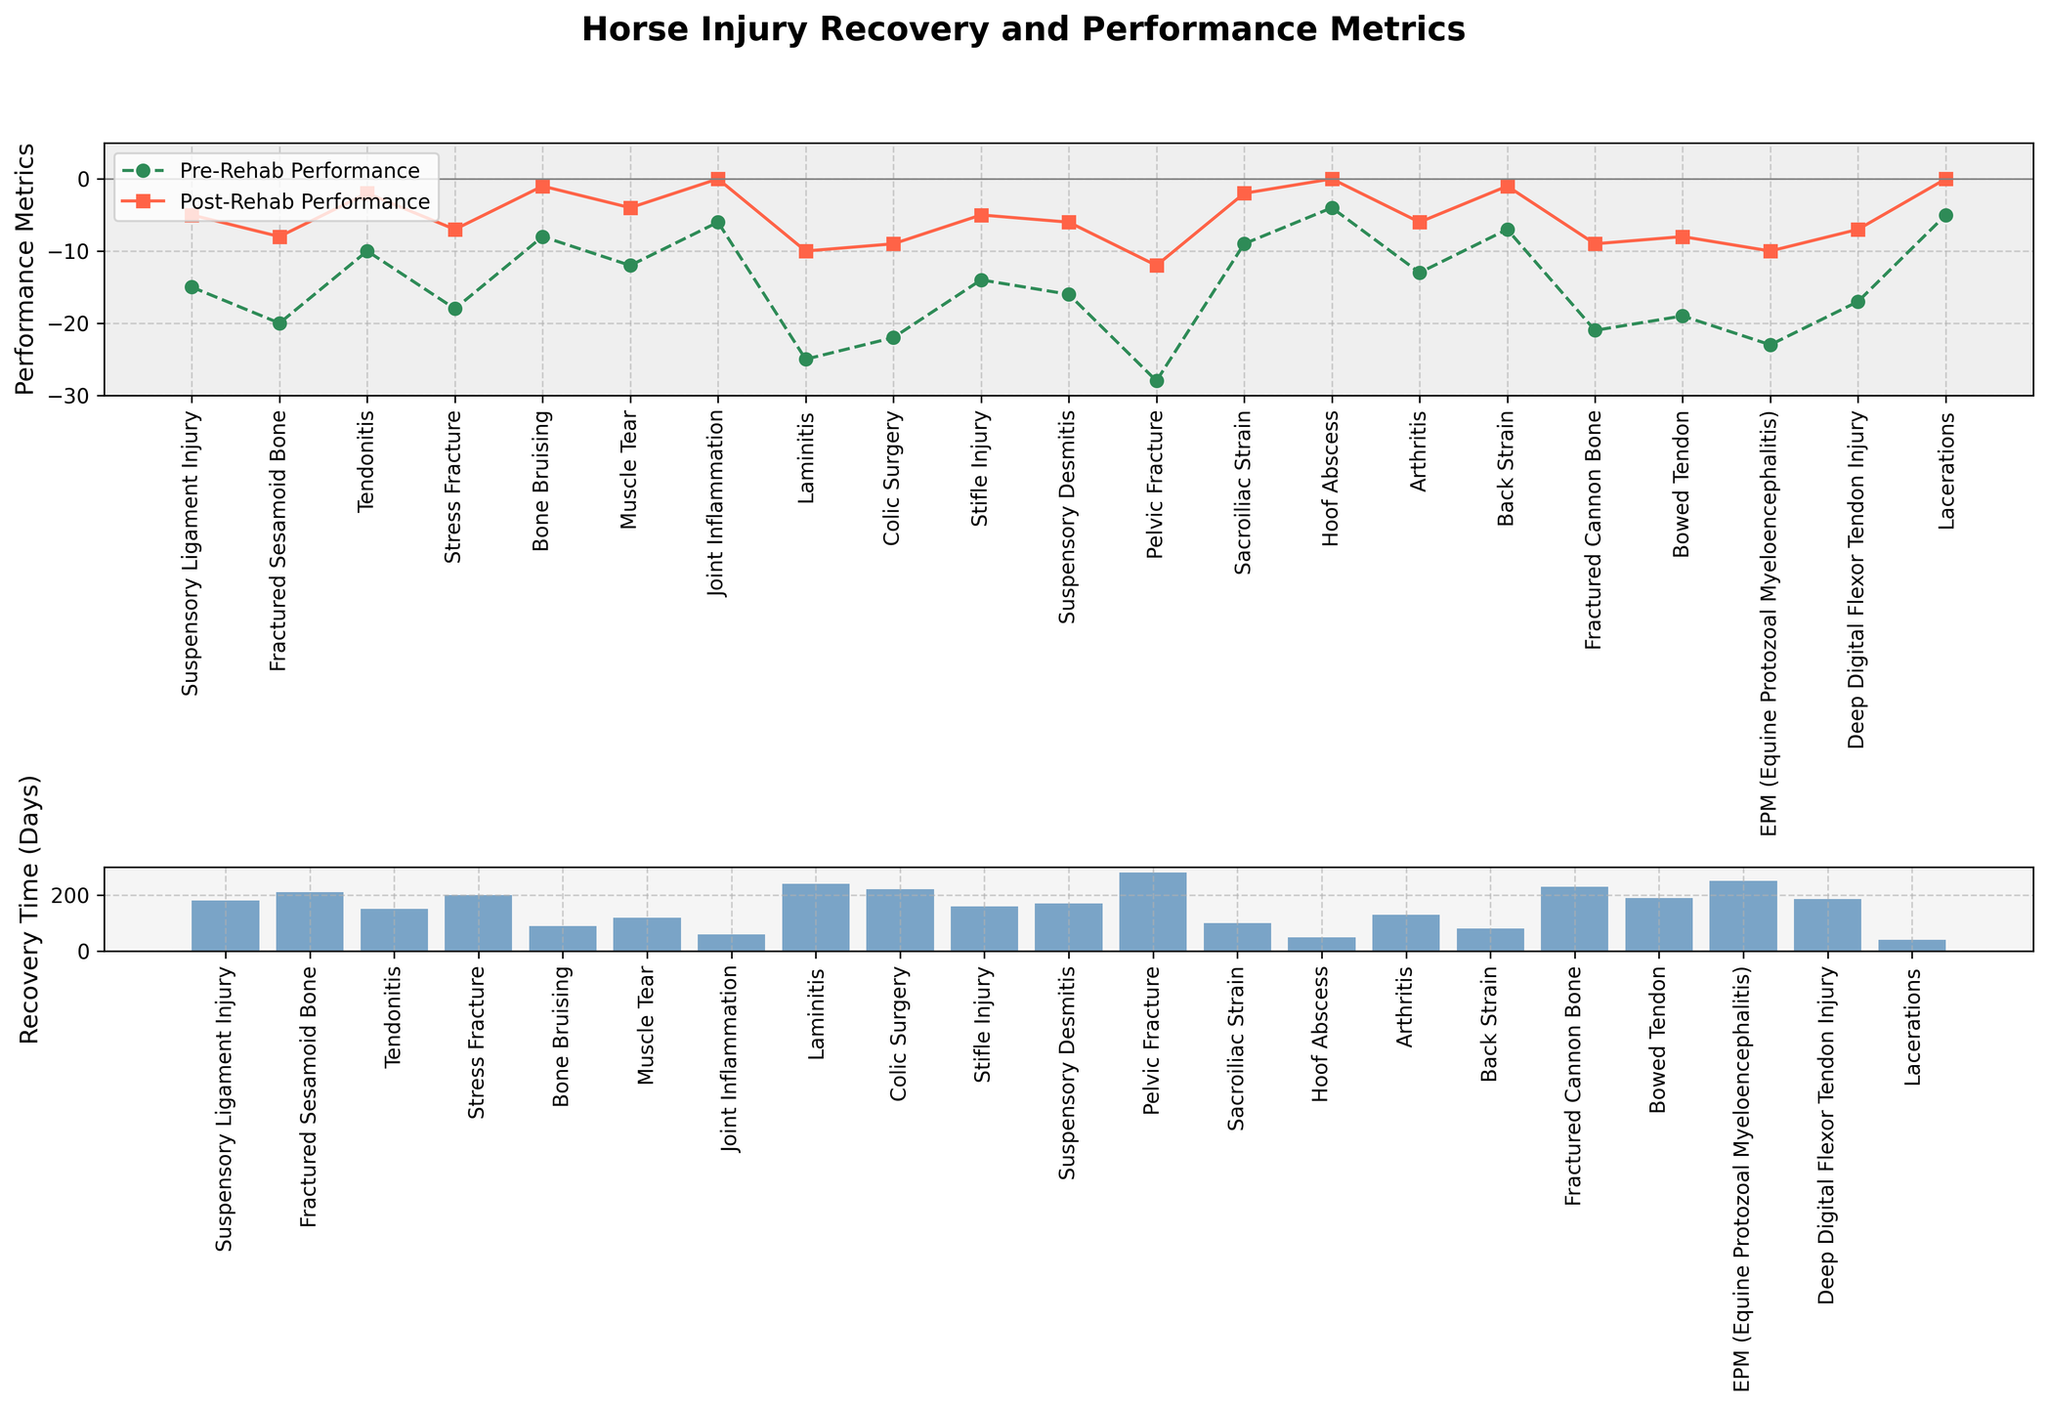What is the average recovery time for suspensory ligament injury and tendonitis? To find the average, add the recovery times for the suspensory ligament injury (180 days) and tendonitis (150 days) and divide by 2: (180 + 150) / 2 = 165 days
Answer: 165 days Which injury has the most significant improvement in performance metrics from pre-rehab to post-rehab? By comparing the differences between pre-rehab and post-rehab performance for each injury, the differences are: Suspensory Ligament Injury (10), Fractured Sesamoid Bone (12), Tendonitis (8), Stress Fracture (11), Bone Bruising (7), Muscle Tear (8), Joint Inflammation (6), Laminitis (15), Colic Surgery (13), Stifle Injury (9), Suspensory Desmitis (10), Pelvic Fracture (16), Sacroiliac Strain (7), Hoof Abscess (4), Arthritis (7), Back Strain (6), Fractured Cannon Bone (12), Bowed Tendon (11), EPM (13), Deep Digital Flexor Tendon Injury (10), Lacerations (5). The pelvic fracture shows the most significant improvement with a difference of 16
Answer: Pelvic Fracture How many injuries have a post-rehab performance of zero? Count the injuries with a post-rehab performance value of zero: Joint Inflammation, Hoof Abscess, and Lacerations
Answer: 3 injuries Which injury has both the longest recovery time and the lowest post-rehab performance? The injuries with the longest recovery times are Pelvic Fracture (280 days) and EPM (250 days). Pelvic Fracture has the lowest post-rehab performance of -12
Answer: Pelvic Fracture Does the injury with the highest recovery time have a higher or lower post-rehab performance than the average post-rehab performance of all injuries? First, find the post-rehab performance of the injury with the highest recovery time, which is Pelvic Fracture with a post-rehab performance of -12. Calculate the average post-rehab performance of all injuries: (-5 + -8 + -2 + -7 + -1 + -4 + 0 + -10 + -9 + -5 + -6 + -12 + -2 + 0 + -6 + -1 + -9 + -8 + -10 + -7 + 0) / 21 = -6.095. So, -12 is less than -6.095
Answer: Lower Which injury has a pre-rehab performance closest to the overall average pre-rehab performance? Calculate the average pre-rehab performance of all injuries: (-15 + -20 + -10 + -18 + -8 + -12 + -6 + -25 + -22 + -14 + -16 + -28 + -9 + -4 + -13 + -7 + -21 + -19 + -23 + -17 + -5) / 21 = -14. So, the injury with the closest pre-rehab performance is Stifle Injury
Answer: Stifle Injury What is the difference in recovery time between the injury with the highest pre-rehab performance and the one with the lowest pre-rehab performance? The injury with the highest pre-rehab performance is Hoof Abscess (-4) and the one with the lowest is Pelvic Fracture (-28). The recovery times are 50 days and 280 days, respectively. The difference is 280 - 50 = 230 days
Answer: 230 days Which injury shows no improvement or decline in performance post-rehab? Look for injuries with no change from pre-rehab to post-rehab performance: Joint Inflammation, Hoof Abscess, and Lacerations all have zero post-rehab performance
Answer: Joint Inflammation, Hoof Abscess, Lacerations 